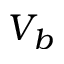Convert formula to latex. <formula><loc_0><loc_0><loc_500><loc_500>V _ { b }</formula> 